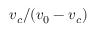Convert formula to latex. <formula><loc_0><loc_0><loc_500><loc_500>v _ { c } / ( v _ { 0 } - v _ { c } )</formula> 